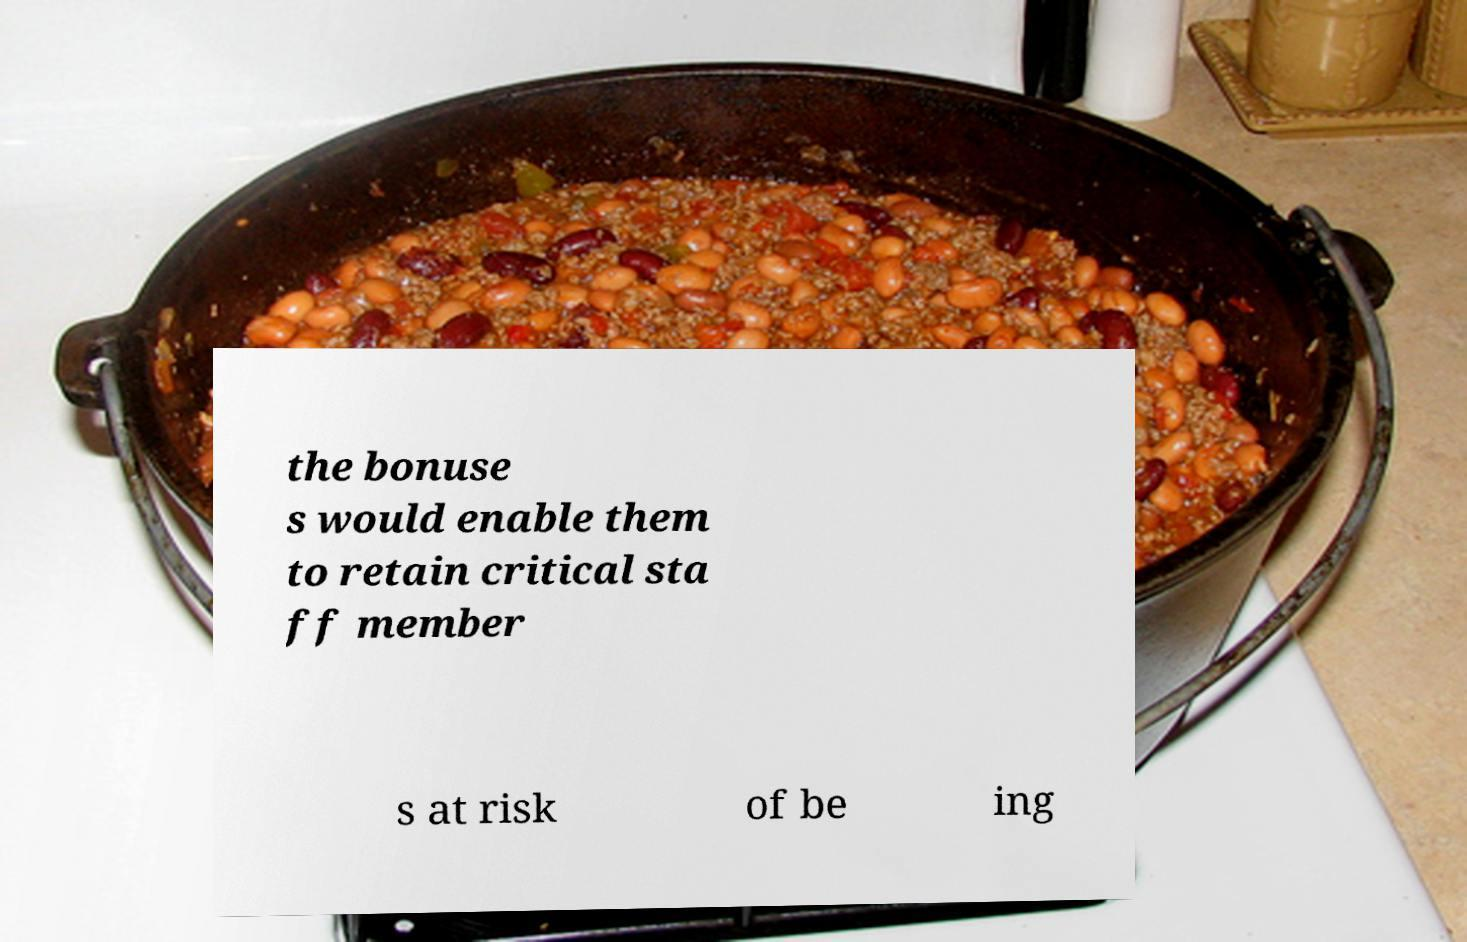Please read and relay the text visible in this image. What does it say? the bonuse s would enable them to retain critical sta ff member s at risk of be ing 